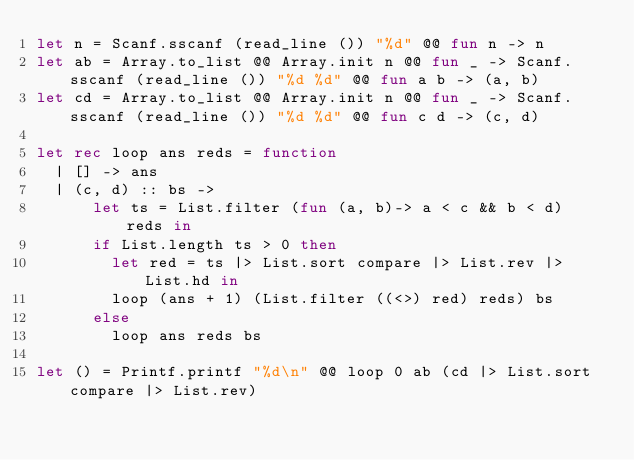Convert code to text. <code><loc_0><loc_0><loc_500><loc_500><_OCaml_>let n = Scanf.sscanf (read_line ()) "%d" @@ fun n -> n
let ab = Array.to_list @@ Array.init n @@ fun _ -> Scanf.sscanf (read_line ()) "%d %d" @@ fun a b -> (a, b)
let cd = Array.to_list @@ Array.init n @@ fun _ -> Scanf.sscanf (read_line ()) "%d %d" @@ fun c d -> (c, d)

let rec loop ans reds = function
  | [] -> ans
  | (c, d) :: bs ->
      let ts = List.filter (fun (a, b)-> a < c && b < d) reds in
      if List.length ts > 0 then
        let red = ts |> List.sort compare |> List.rev |> List.hd in
        loop (ans + 1) (List.filter ((<>) red) reds) bs
      else 
        loop ans reds bs

let () = Printf.printf "%d\n" @@ loop 0 ab (cd |> List.sort compare |> List.rev)</code> 